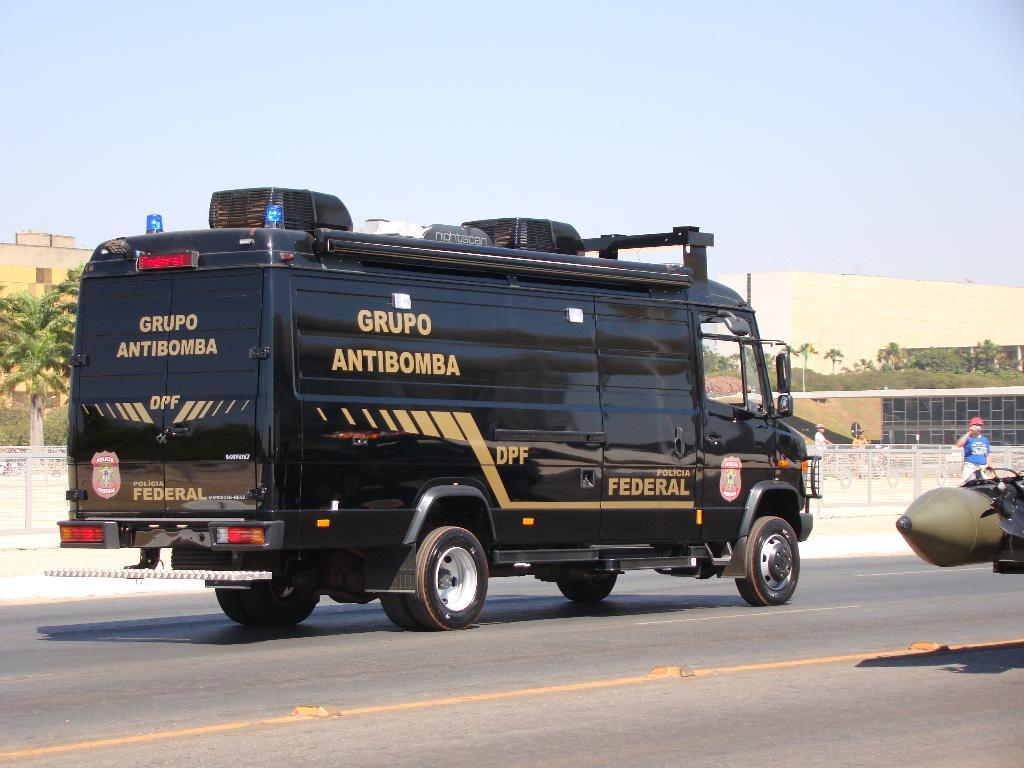<image>
Summarize the visual content of the image. A large federal van that says Grupo Antibomba is driving down a road. 